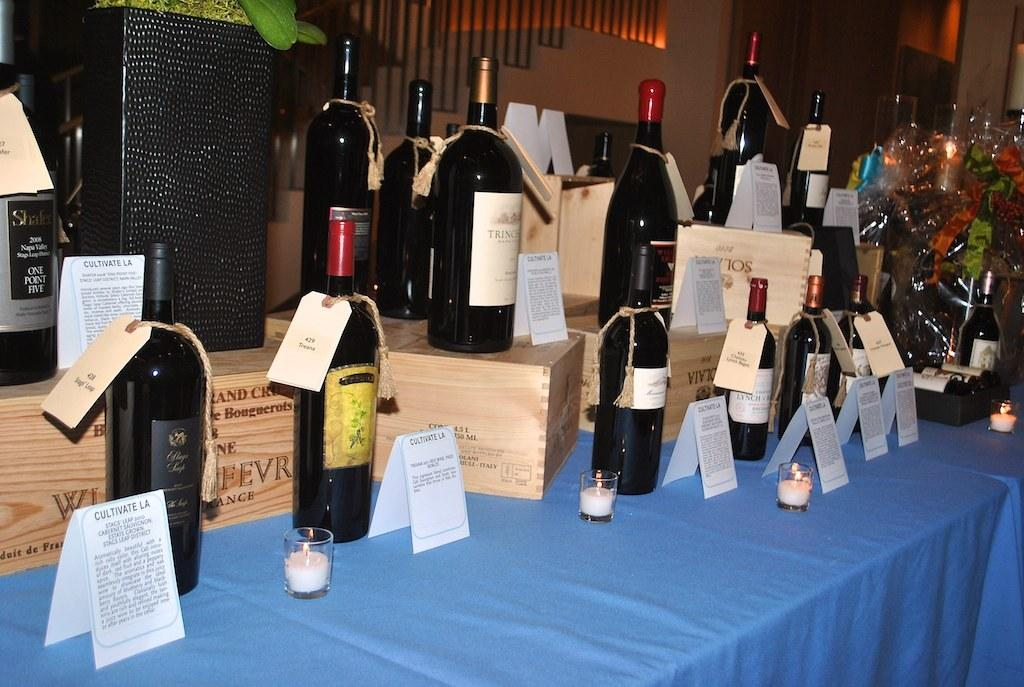Provide a one-sentence caption for the provided image. A whole bunch of white bottles on a table with Cultivate LA cards in front of them. 